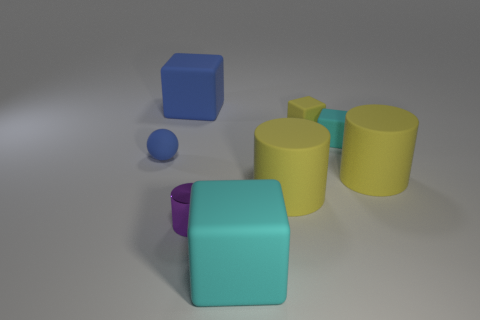What is the size of the yellow thing that is the same shape as the tiny cyan matte thing?
Provide a short and direct response. Small. There is a small sphere that is made of the same material as the big blue thing; what color is it?
Offer a very short reply. Blue. Is the number of small metal cylinders behind the purple cylinder the same as the number of small blue blocks?
Your answer should be compact. Yes. Is the size of the matte cube in front of the blue sphere the same as the blue rubber block?
Your answer should be compact. Yes. There is a matte sphere that is the same size as the purple thing; what color is it?
Ensure brevity in your answer.  Blue. There is a big cube that is in front of the small rubber thing to the right of the yellow rubber block; is there a metallic cylinder on the right side of it?
Your answer should be very brief. No. What is the material of the cylinder left of the big cyan matte thing?
Keep it short and to the point. Metal. There is a purple shiny object; is it the same shape as the tiny matte object that is left of the tiny yellow block?
Your answer should be very brief. No. Are there the same number of spheres in front of the small rubber sphere and cylinders on the left side of the tiny yellow matte block?
Keep it short and to the point. No. How many other things are there of the same material as the purple object?
Offer a terse response. 0. 